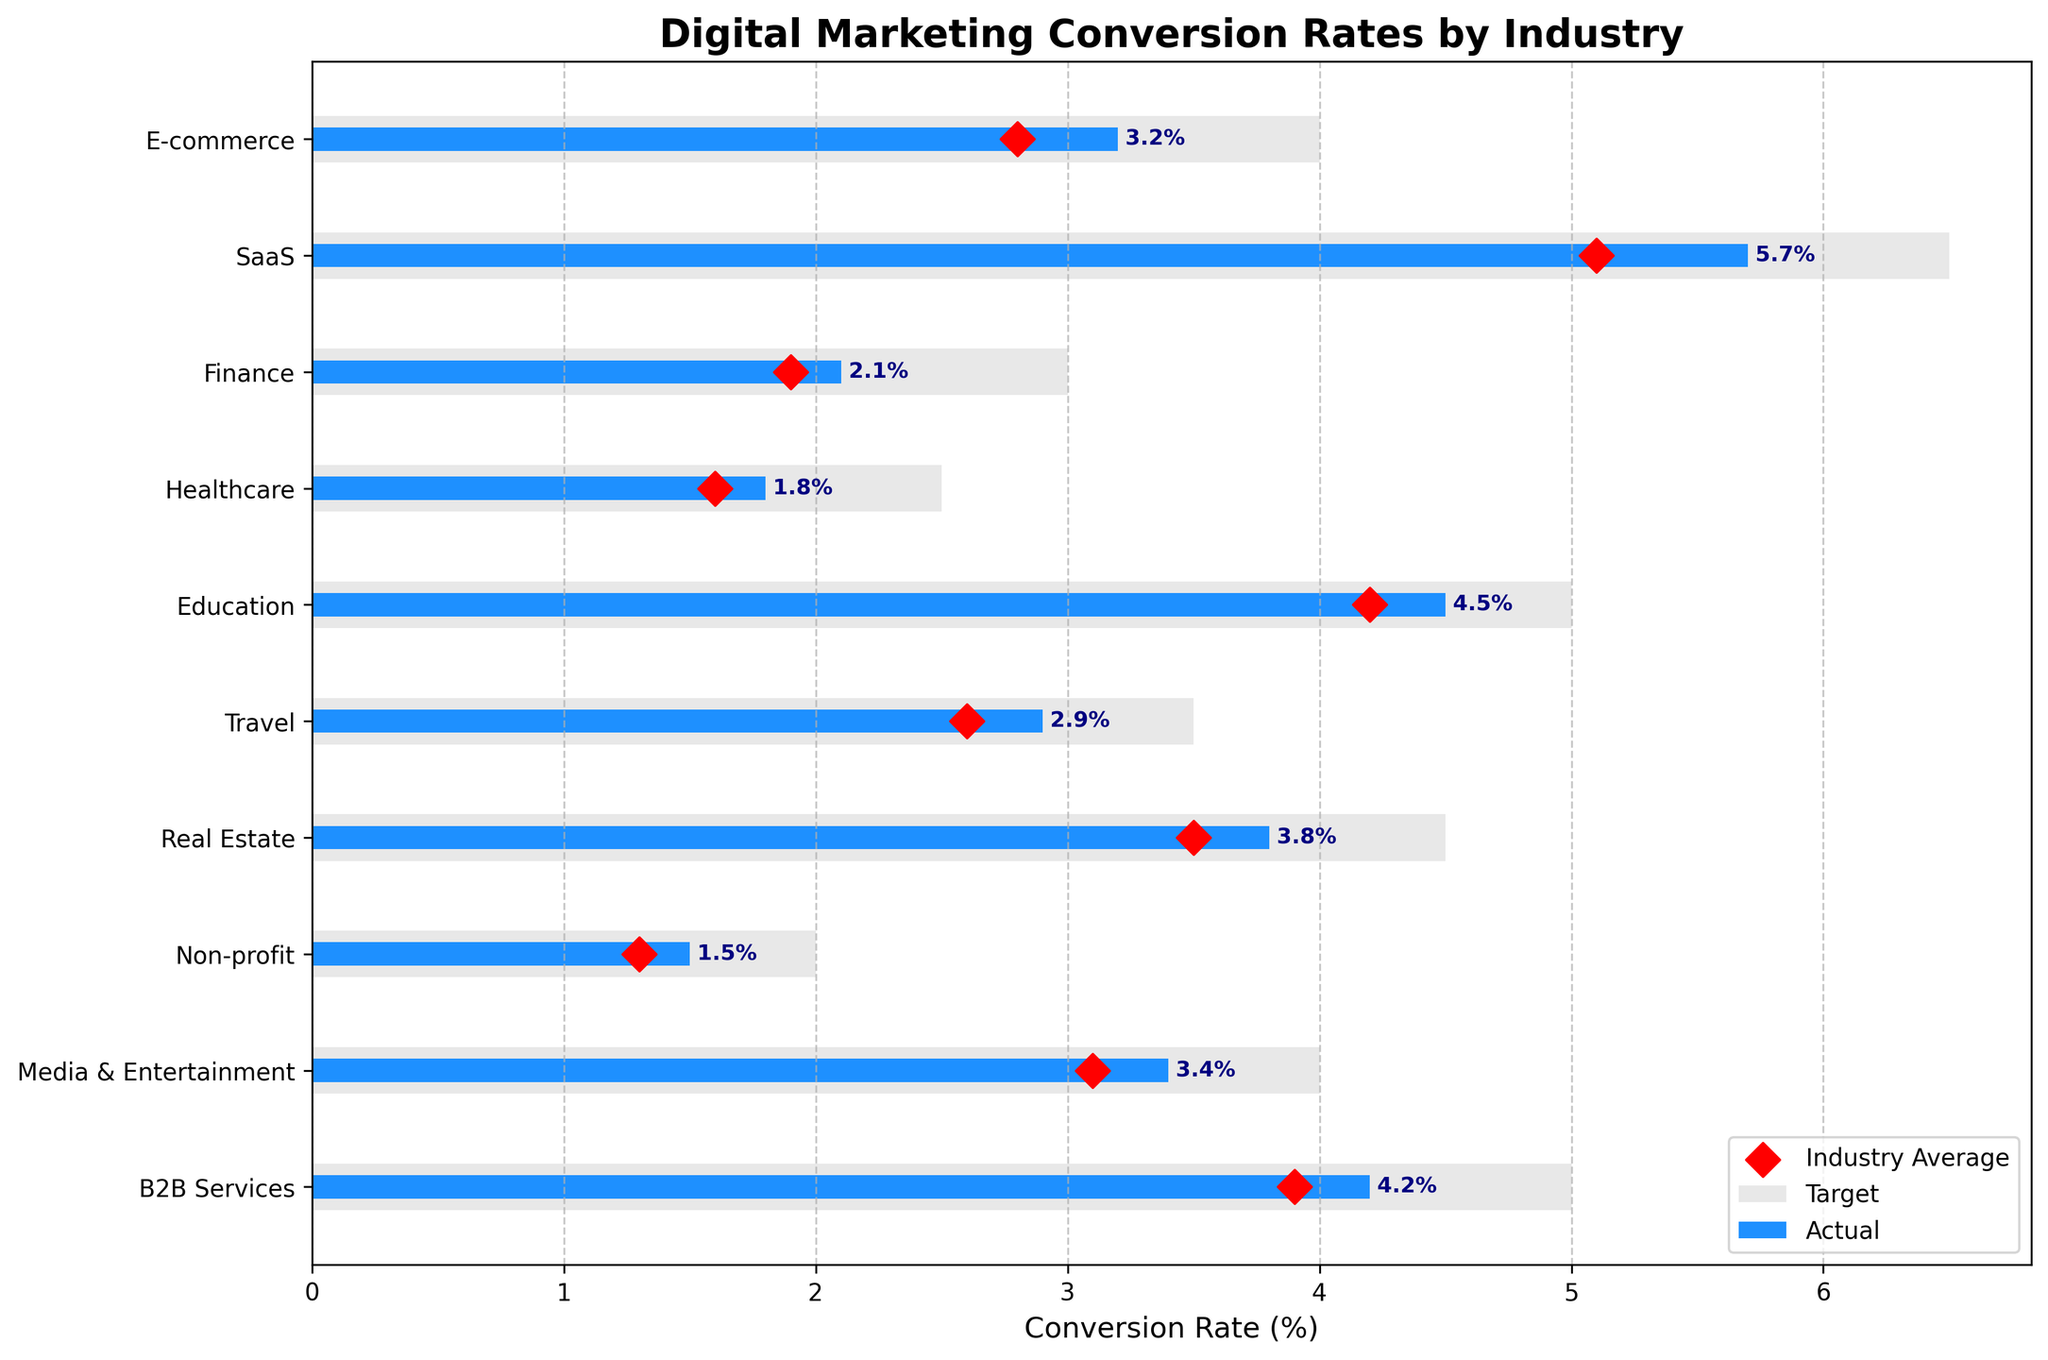What's the title of the figure? The title of the figure is shown at the top in bold text. It reads "Digital Marketing Conversion Rates by Industry".
Answer: Digital Marketing Conversion Rates by Industry Which industry has the highest actual conversion rate? By looking at the blue bars, we can see that SaaS has the highest actual conversion rate, reaching up to 5.7%.
Answer: SaaS What is the target conversion rate for the Real Estate industry? The grey bar representing the target rate for Real Estate extends to the value of 4.5%.
Answer: 4.5% How many industries are plotted in the figure? Each bar or data point on the y-axis corresponds to an industry. By counting these, we get a total of 10 industries.
Answer: 10 What is the difference between the actual and target conversion rates for the Healthcare industry? Subtract the actual conversion rate for Healthcare (1.8%) from the target conversion rate (2.5%). 2.5% - 1.8% = 0.7%.
Answer: 0.7% Which industry has the smallest gap between actual and industry average conversion rates? Compare the differences between the blue bars and the red diamonds for all industries. The Non-profit industry has the smallest gap: its actual rate is 1.5% and industry average is 1.3%, a difference of 0.2%.
Answer: Non-profit What are the conversion rates (actual, target, and industry average) for the Media & Entertainment industry? Refer to the blue bar for actual (3.4%), grey bar for target (4.0%), and the red marker for industry average (3.1%).
Answer: Actual: 3.4%, Target: 4.0%, Industry Average: 3.1% Which industries have actual conversion rates that meet or exceed their industry averages? Industries whose blue bars (actual rates) are equal to or higher than their red diamond markers (industry averages) are: E-commerce, SaaS, Media & Entertainment, and B2B Services.
Answer: E-commerce, SaaS, Media & Entertainment, B2B Services Is there any industry where the actual conversion rate exceeds the target conversion rate? Compare blue bars (actual rates) to grey bars (target rates) for all industries. There is no industry where the actual conversion rate exceeds the target.
Answer: No Which industry is closest to meeting its target conversion rate? Calculate the difference between the actual and target rates for each industry. The Education industry, with actual 4.5% and target 5.0%, has a difference of 0.5%, which is the closest gap.
Answer: Education 